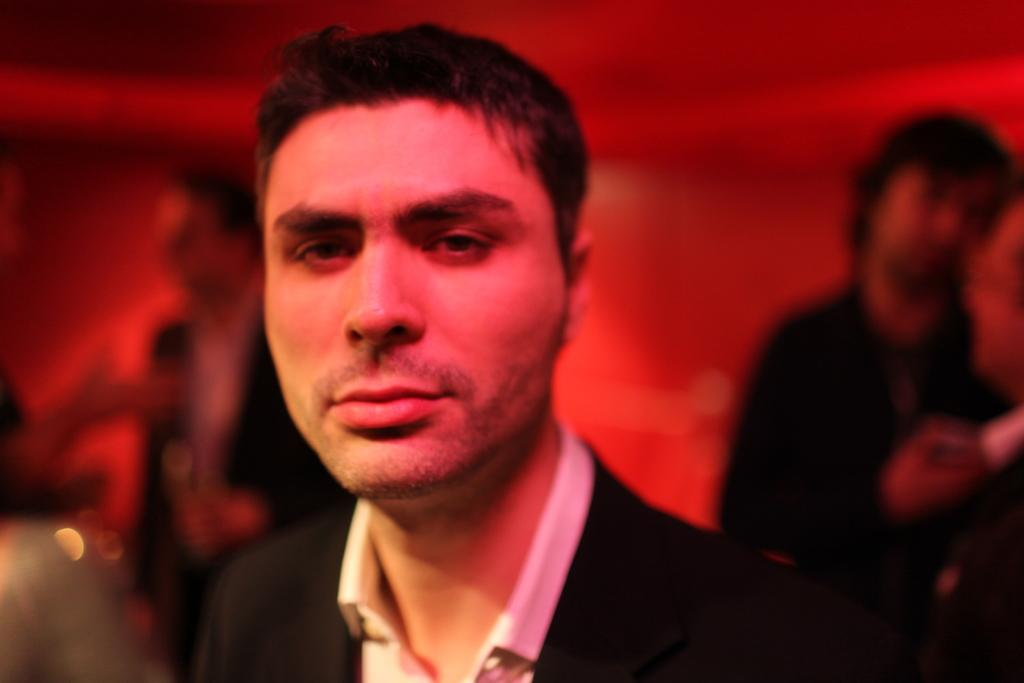Who or what is present in the image? There are people in the image. What can be observed about the background of the image? The background of the image is red in color. What type of coach is being rewarded in the image? There is no coach or reward present in the image; it only features people with a red background. 